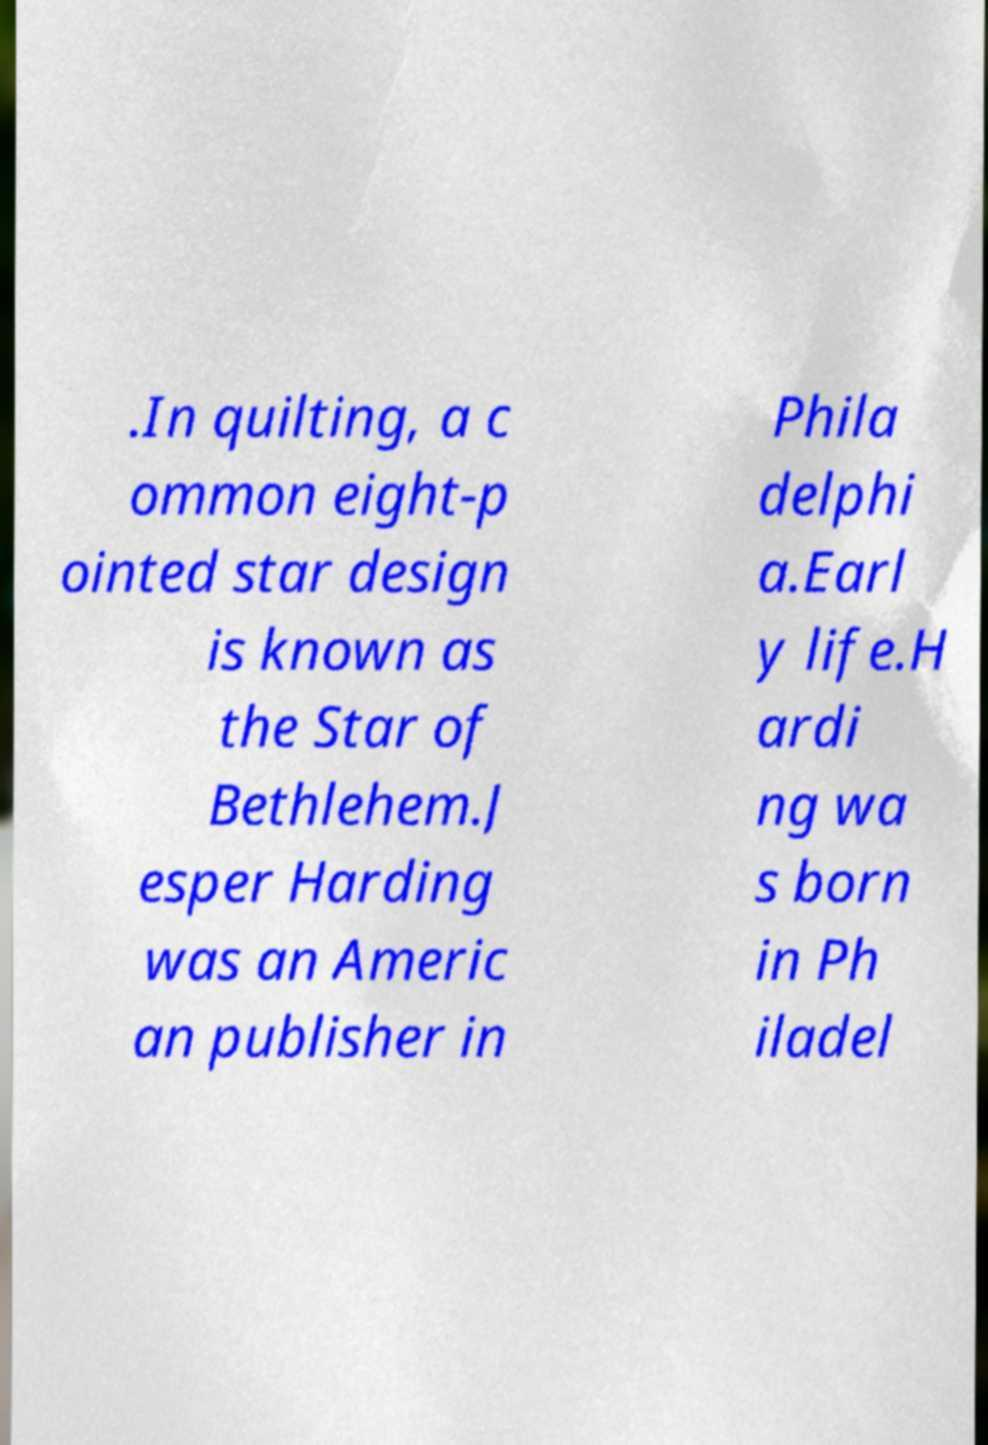For documentation purposes, I need the text within this image transcribed. Could you provide that? .In quilting, a c ommon eight-p ointed star design is known as the Star of Bethlehem.J esper Harding was an Americ an publisher in Phila delphi a.Earl y life.H ardi ng wa s born in Ph iladel 